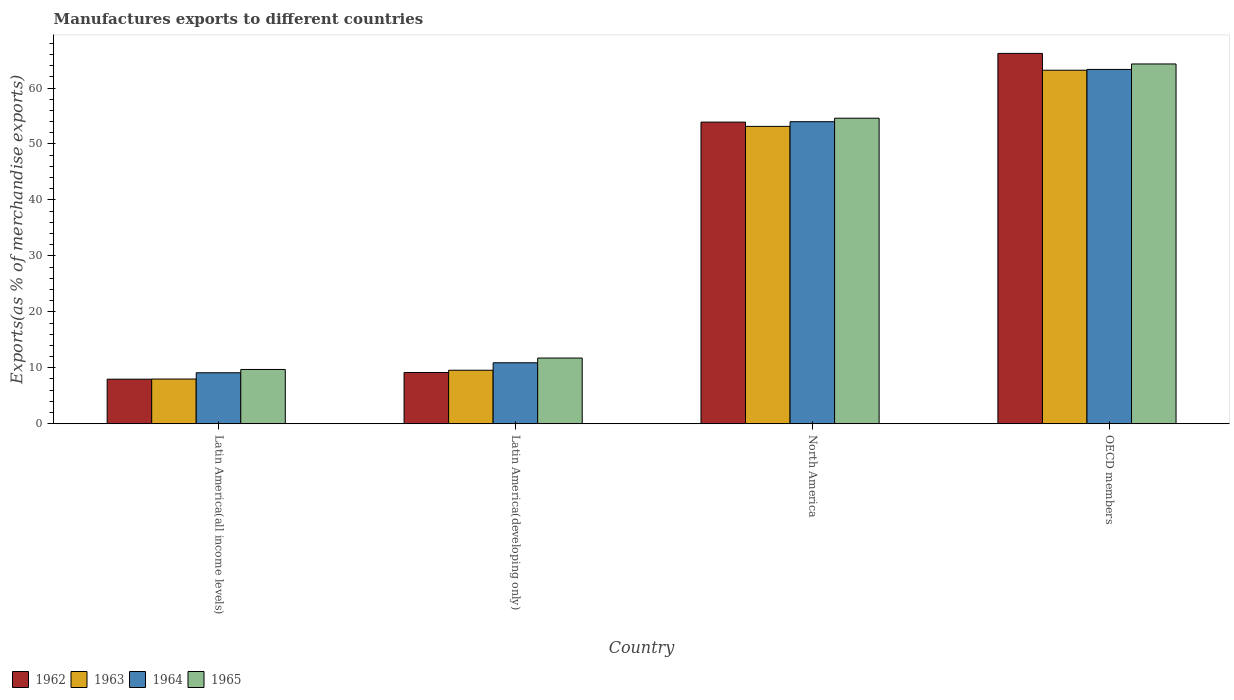How many groups of bars are there?
Your answer should be very brief. 4. Are the number of bars per tick equal to the number of legend labels?
Offer a terse response. Yes. What is the label of the 3rd group of bars from the left?
Give a very brief answer. North America. In how many cases, is the number of bars for a given country not equal to the number of legend labels?
Provide a succinct answer. 0. What is the percentage of exports to different countries in 1962 in OECD members?
Give a very brief answer. 66.19. Across all countries, what is the maximum percentage of exports to different countries in 1965?
Give a very brief answer. 64.3. Across all countries, what is the minimum percentage of exports to different countries in 1964?
Your answer should be very brief. 9.11. In which country was the percentage of exports to different countries in 1963 minimum?
Keep it short and to the point. Latin America(all income levels). What is the total percentage of exports to different countries in 1964 in the graph?
Offer a terse response. 137.31. What is the difference between the percentage of exports to different countries in 1965 in Latin America(all income levels) and that in Latin America(developing only)?
Provide a short and direct response. -2.04. What is the difference between the percentage of exports to different countries in 1963 in Latin America(developing only) and the percentage of exports to different countries in 1964 in North America?
Keep it short and to the point. -44.42. What is the average percentage of exports to different countries in 1962 per country?
Your answer should be very brief. 34.31. What is the difference between the percentage of exports to different countries of/in 1964 and percentage of exports to different countries of/in 1965 in Latin America(developing only)?
Make the answer very short. -0.84. What is the ratio of the percentage of exports to different countries in 1962 in Latin America(all income levels) to that in OECD members?
Provide a short and direct response. 0.12. Is the percentage of exports to different countries in 1965 in Latin America(developing only) less than that in OECD members?
Give a very brief answer. Yes. Is the difference between the percentage of exports to different countries in 1964 in Latin America(developing only) and OECD members greater than the difference between the percentage of exports to different countries in 1965 in Latin America(developing only) and OECD members?
Offer a very short reply. Yes. What is the difference between the highest and the second highest percentage of exports to different countries in 1963?
Ensure brevity in your answer.  -43.59. What is the difference between the highest and the lowest percentage of exports to different countries in 1965?
Your answer should be compact. 54.6. In how many countries, is the percentage of exports to different countries in 1965 greater than the average percentage of exports to different countries in 1965 taken over all countries?
Offer a very short reply. 2. What does the 2nd bar from the right in Latin America(developing only) represents?
Your answer should be very brief. 1964. Is it the case that in every country, the sum of the percentage of exports to different countries in 1965 and percentage of exports to different countries in 1963 is greater than the percentage of exports to different countries in 1964?
Your response must be concise. Yes. How many countries are there in the graph?
Ensure brevity in your answer.  4. Does the graph contain grids?
Ensure brevity in your answer.  No. How many legend labels are there?
Provide a short and direct response. 4. How are the legend labels stacked?
Your response must be concise. Horizontal. What is the title of the graph?
Your answer should be very brief. Manufactures exports to different countries. What is the label or title of the Y-axis?
Make the answer very short. Exports(as % of merchandise exports). What is the Exports(as % of merchandise exports) in 1962 in Latin America(all income levels)?
Provide a succinct answer. 7.96. What is the Exports(as % of merchandise exports) of 1963 in Latin America(all income levels)?
Your answer should be compact. 7.99. What is the Exports(as % of merchandise exports) of 1964 in Latin America(all income levels)?
Keep it short and to the point. 9.11. What is the Exports(as % of merchandise exports) in 1965 in Latin America(all income levels)?
Ensure brevity in your answer.  9.7. What is the Exports(as % of merchandise exports) in 1962 in Latin America(developing only)?
Offer a very short reply. 9.16. What is the Exports(as % of merchandise exports) of 1963 in Latin America(developing only)?
Make the answer very short. 9.56. What is the Exports(as % of merchandise exports) of 1964 in Latin America(developing only)?
Provide a short and direct response. 10.9. What is the Exports(as % of merchandise exports) in 1965 in Latin America(developing only)?
Ensure brevity in your answer.  11.74. What is the Exports(as % of merchandise exports) in 1962 in North America?
Ensure brevity in your answer.  53.91. What is the Exports(as % of merchandise exports) in 1963 in North America?
Give a very brief answer. 53.15. What is the Exports(as % of merchandise exports) of 1964 in North America?
Provide a succinct answer. 53.98. What is the Exports(as % of merchandise exports) of 1965 in North America?
Your response must be concise. 54.61. What is the Exports(as % of merchandise exports) of 1962 in OECD members?
Ensure brevity in your answer.  66.19. What is the Exports(as % of merchandise exports) of 1963 in OECD members?
Provide a short and direct response. 63.18. What is the Exports(as % of merchandise exports) of 1964 in OECD members?
Your answer should be very brief. 63.32. What is the Exports(as % of merchandise exports) of 1965 in OECD members?
Offer a terse response. 64.3. Across all countries, what is the maximum Exports(as % of merchandise exports) of 1962?
Give a very brief answer. 66.19. Across all countries, what is the maximum Exports(as % of merchandise exports) in 1963?
Make the answer very short. 63.18. Across all countries, what is the maximum Exports(as % of merchandise exports) of 1964?
Make the answer very short. 63.32. Across all countries, what is the maximum Exports(as % of merchandise exports) in 1965?
Give a very brief answer. 64.3. Across all countries, what is the minimum Exports(as % of merchandise exports) in 1962?
Provide a succinct answer. 7.96. Across all countries, what is the minimum Exports(as % of merchandise exports) in 1963?
Offer a terse response. 7.99. Across all countries, what is the minimum Exports(as % of merchandise exports) of 1964?
Your response must be concise. 9.11. Across all countries, what is the minimum Exports(as % of merchandise exports) of 1965?
Make the answer very short. 9.7. What is the total Exports(as % of merchandise exports) of 1962 in the graph?
Your answer should be very brief. 137.22. What is the total Exports(as % of merchandise exports) in 1963 in the graph?
Offer a terse response. 133.88. What is the total Exports(as % of merchandise exports) of 1964 in the graph?
Your answer should be very brief. 137.31. What is the total Exports(as % of merchandise exports) of 1965 in the graph?
Ensure brevity in your answer.  140.35. What is the difference between the Exports(as % of merchandise exports) of 1962 in Latin America(all income levels) and that in Latin America(developing only)?
Provide a short and direct response. -1.2. What is the difference between the Exports(as % of merchandise exports) of 1963 in Latin America(all income levels) and that in Latin America(developing only)?
Provide a short and direct response. -1.57. What is the difference between the Exports(as % of merchandise exports) in 1964 in Latin America(all income levels) and that in Latin America(developing only)?
Give a very brief answer. -1.78. What is the difference between the Exports(as % of merchandise exports) in 1965 in Latin America(all income levels) and that in Latin America(developing only)?
Give a very brief answer. -2.04. What is the difference between the Exports(as % of merchandise exports) in 1962 in Latin America(all income levels) and that in North America?
Offer a terse response. -45.94. What is the difference between the Exports(as % of merchandise exports) of 1963 in Latin America(all income levels) and that in North America?
Ensure brevity in your answer.  -45.16. What is the difference between the Exports(as % of merchandise exports) in 1964 in Latin America(all income levels) and that in North America?
Make the answer very short. -44.87. What is the difference between the Exports(as % of merchandise exports) of 1965 in Latin America(all income levels) and that in North America?
Provide a succinct answer. -44.91. What is the difference between the Exports(as % of merchandise exports) of 1962 in Latin America(all income levels) and that in OECD members?
Offer a terse response. -58.23. What is the difference between the Exports(as % of merchandise exports) in 1963 in Latin America(all income levels) and that in OECD members?
Provide a short and direct response. -55.19. What is the difference between the Exports(as % of merchandise exports) in 1964 in Latin America(all income levels) and that in OECD members?
Your answer should be very brief. -54.21. What is the difference between the Exports(as % of merchandise exports) of 1965 in Latin America(all income levels) and that in OECD members?
Ensure brevity in your answer.  -54.6. What is the difference between the Exports(as % of merchandise exports) of 1962 in Latin America(developing only) and that in North America?
Give a very brief answer. -44.75. What is the difference between the Exports(as % of merchandise exports) of 1963 in Latin America(developing only) and that in North America?
Your response must be concise. -43.59. What is the difference between the Exports(as % of merchandise exports) in 1964 in Latin America(developing only) and that in North America?
Offer a very short reply. -43.09. What is the difference between the Exports(as % of merchandise exports) of 1965 in Latin America(developing only) and that in North America?
Provide a short and direct response. -42.87. What is the difference between the Exports(as % of merchandise exports) of 1962 in Latin America(developing only) and that in OECD members?
Provide a short and direct response. -57.03. What is the difference between the Exports(as % of merchandise exports) of 1963 in Latin America(developing only) and that in OECD members?
Keep it short and to the point. -53.62. What is the difference between the Exports(as % of merchandise exports) in 1964 in Latin America(developing only) and that in OECD members?
Provide a short and direct response. -52.43. What is the difference between the Exports(as % of merchandise exports) of 1965 in Latin America(developing only) and that in OECD members?
Provide a short and direct response. -52.56. What is the difference between the Exports(as % of merchandise exports) of 1962 in North America and that in OECD members?
Make the answer very short. -12.28. What is the difference between the Exports(as % of merchandise exports) in 1963 in North America and that in OECD members?
Make the answer very short. -10.03. What is the difference between the Exports(as % of merchandise exports) of 1964 in North America and that in OECD members?
Make the answer very short. -9.34. What is the difference between the Exports(as % of merchandise exports) of 1965 in North America and that in OECD members?
Ensure brevity in your answer.  -9.7. What is the difference between the Exports(as % of merchandise exports) of 1962 in Latin America(all income levels) and the Exports(as % of merchandise exports) of 1963 in Latin America(developing only)?
Offer a very short reply. -1.6. What is the difference between the Exports(as % of merchandise exports) in 1962 in Latin America(all income levels) and the Exports(as % of merchandise exports) in 1964 in Latin America(developing only)?
Your answer should be very brief. -2.93. What is the difference between the Exports(as % of merchandise exports) in 1962 in Latin America(all income levels) and the Exports(as % of merchandise exports) in 1965 in Latin America(developing only)?
Offer a terse response. -3.78. What is the difference between the Exports(as % of merchandise exports) of 1963 in Latin America(all income levels) and the Exports(as % of merchandise exports) of 1964 in Latin America(developing only)?
Your response must be concise. -2.91. What is the difference between the Exports(as % of merchandise exports) of 1963 in Latin America(all income levels) and the Exports(as % of merchandise exports) of 1965 in Latin America(developing only)?
Provide a short and direct response. -3.75. What is the difference between the Exports(as % of merchandise exports) in 1964 in Latin America(all income levels) and the Exports(as % of merchandise exports) in 1965 in Latin America(developing only)?
Keep it short and to the point. -2.63. What is the difference between the Exports(as % of merchandise exports) in 1962 in Latin America(all income levels) and the Exports(as % of merchandise exports) in 1963 in North America?
Offer a very short reply. -45.18. What is the difference between the Exports(as % of merchandise exports) of 1962 in Latin America(all income levels) and the Exports(as % of merchandise exports) of 1964 in North America?
Your response must be concise. -46.02. What is the difference between the Exports(as % of merchandise exports) in 1962 in Latin America(all income levels) and the Exports(as % of merchandise exports) in 1965 in North America?
Ensure brevity in your answer.  -46.64. What is the difference between the Exports(as % of merchandise exports) in 1963 in Latin America(all income levels) and the Exports(as % of merchandise exports) in 1964 in North America?
Give a very brief answer. -45.99. What is the difference between the Exports(as % of merchandise exports) in 1963 in Latin America(all income levels) and the Exports(as % of merchandise exports) in 1965 in North America?
Your response must be concise. -46.62. What is the difference between the Exports(as % of merchandise exports) of 1964 in Latin America(all income levels) and the Exports(as % of merchandise exports) of 1965 in North America?
Offer a terse response. -45.49. What is the difference between the Exports(as % of merchandise exports) of 1962 in Latin America(all income levels) and the Exports(as % of merchandise exports) of 1963 in OECD members?
Your response must be concise. -55.22. What is the difference between the Exports(as % of merchandise exports) in 1962 in Latin America(all income levels) and the Exports(as % of merchandise exports) in 1964 in OECD members?
Your answer should be compact. -55.36. What is the difference between the Exports(as % of merchandise exports) of 1962 in Latin America(all income levels) and the Exports(as % of merchandise exports) of 1965 in OECD members?
Offer a terse response. -56.34. What is the difference between the Exports(as % of merchandise exports) in 1963 in Latin America(all income levels) and the Exports(as % of merchandise exports) in 1964 in OECD members?
Offer a very short reply. -55.34. What is the difference between the Exports(as % of merchandise exports) of 1963 in Latin America(all income levels) and the Exports(as % of merchandise exports) of 1965 in OECD members?
Provide a short and direct response. -56.31. What is the difference between the Exports(as % of merchandise exports) of 1964 in Latin America(all income levels) and the Exports(as % of merchandise exports) of 1965 in OECD members?
Offer a very short reply. -55.19. What is the difference between the Exports(as % of merchandise exports) in 1962 in Latin America(developing only) and the Exports(as % of merchandise exports) in 1963 in North America?
Ensure brevity in your answer.  -43.99. What is the difference between the Exports(as % of merchandise exports) in 1962 in Latin America(developing only) and the Exports(as % of merchandise exports) in 1964 in North America?
Keep it short and to the point. -44.82. What is the difference between the Exports(as % of merchandise exports) in 1962 in Latin America(developing only) and the Exports(as % of merchandise exports) in 1965 in North America?
Make the answer very short. -45.45. What is the difference between the Exports(as % of merchandise exports) in 1963 in Latin America(developing only) and the Exports(as % of merchandise exports) in 1964 in North America?
Keep it short and to the point. -44.42. What is the difference between the Exports(as % of merchandise exports) of 1963 in Latin America(developing only) and the Exports(as % of merchandise exports) of 1965 in North America?
Offer a very short reply. -45.04. What is the difference between the Exports(as % of merchandise exports) of 1964 in Latin America(developing only) and the Exports(as % of merchandise exports) of 1965 in North America?
Ensure brevity in your answer.  -43.71. What is the difference between the Exports(as % of merchandise exports) of 1962 in Latin America(developing only) and the Exports(as % of merchandise exports) of 1963 in OECD members?
Provide a short and direct response. -54.02. What is the difference between the Exports(as % of merchandise exports) of 1962 in Latin America(developing only) and the Exports(as % of merchandise exports) of 1964 in OECD members?
Your response must be concise. -54.16. What is the difference between the Exports(as % of merchandise exports) of 1962 in Latin America(developing only) and the Exports(as % of merchandise exports) of 1965 in OECD members?
Provide a succinct answer. -55.14. What is the difference between the Exports(as % of merchandise exports) of 1963 in Latin America(developing only) and the Exports(as % of merchandise exports) of 1964 in OECD members?
Your response must be concise. -53.76. What is the difference between the Exports(as % of merchandise exports) of 1963 in Latin America(developing only) and the Exports(as % of merchandise exports) of 1965 in OECD members?
Your answer should be compact. -54.74. What is the difference between the Exports(as % of merchandise exports) of 1964 in Latin America(developing only) and the Exports(as % of merchandise exports) of 1965 in OECD members?
Give a very brief answer. -53.41. What is the difference between the Exports(as % of merchandise exports) of 1962 in North America and the Exports(as % of merchandise exports) of 1963 in OECD members?
Your answer should be very brief. -9.27. What is the difference between the Exports(as % of merchandise exports) of 1962 in North America and the Exports(as % of merchandise exports) of 1964 in OECD members?
Provide a succinct answer. -9.42. What is the difference between the Exports(as % of merchandise exports) of 1962 in North America and the Exports(as % of merchandise exports) of 1965 in OECD members?
Your answer should be very brief. -10.4. What is the difference between the Exports(as % of merchandise exports) of 1963 in North America and the Exports(as % of merchandise exports) of 1964 in OECD members?
Your response must be concise. -10.18. What is the difference between the Exports(as % of merchandise exports) of 1963 in North America and the Exports(as % of merchandise exports) of 1965 in OECD members?
Provide a short and direct response. -11.15. What is the difference between the Exports(as % of merchandise exports) in 1964 in North America and the Exports(as % of merchandise exports) in 1965 in OECD members?
Provide a short and direct response. -10.32. What is the average Exports(as % of merchandise exports) of 1962 per country?
Ensure brevity in your answer.  34.31. What is the average Exports(as % of merchandise exports) of 1963 per country?
Your answer should be compact. 33.47. What is the average Exports(as % of merchandise exports) of 1964 per country?
Offer a terse response. 34.33. What is the average Exports(as % of merchandise exports) of 1965 per country?
Offer a terse response. 35.09. What is the difference between the Exports(as % of merchandise exports) in 1962 and Exports(as % of merchandise exports) in 1963 in Latin America(all income levels)?
Give a very brief answer. -0.02. What is the difference between the Exports(as % of merchandise exports) in 1962 and Exports(as % of merchandise exports) in 1964 in Latin America(all income levels)?
Ensure brevity in your answer.  -1.15. What is the difference between the Exports(as % of merchandise exports) in 1962 and Exports(as % of merchandise exports) in 1965 in Latin America(all income levels)?
Keep it short and to the point. -1.74. What is the difference between the Exports(as % of merchandise exports) in 1963 and Exports(as % of merchandise exports) in 1964 in Latin America(all income levels)?
Your answer should be compact. -1.12. What is the difference between the Exports(as % of merchandise exports) of 1963 and Exports(as % of merchandise exports) of 1965 in Latin America(all income levels)?
Your response must be concise. -1.71. What is the difference between the Exports(as % of merchandise exports) in 1964 and Exports(as % of merchandise exports) in 1965 in Latin America(all income levels)?
Offer a very short reply. -0.59. What is the difference between the Exports(as % of merchandise exports) in 1962 and Exports(as % of merchandise exports) in 1963 in Latin America(developing only)?
Give a very brief answer. -0.4. What is the difference between the Exports(as % of merchandise exports) of 1962 and Exports(as % of merchandise exports) of 1964 in Latin America(developing only)?
Your answer should be very brief. -1.74. What is the difference between the Exports(as % of merchandise exports) of 1962 and Exports(as % of merchandise exports) of 1965 in Latin America(developing only)?
Provide a short and direct response. -2.58. What is the difference between the Exports(as % of merchandise exports) of 1963 and Exports(as % of merchandise exports) of 1964 in Latin America(developing only)?
Keep it short and to the point. -1.33. What is the difference between the Exports(as % of merchandise exports) in 1963 and Exports(as % of merchandise exports) in 1965 in Latin America(developing only)?
Offer a very short reply. -2.18. What is the difference between the Exports(as % of merchandise exports) of 1964 and Exports(as % of merchandise exports) of 1965 in Latin America(developing only)?
Keep it short and to the point. -0.84. What is the difference between the Exports(as % of merchandise exports) in 1962 and Exports(as % of merchandise exports) in 1963 in North America?
Ensure brevity in your answer.  0.76. What is the difference between the Exports(as % of merchandise exports) of 1962 and Exports(as % of merchandise exports) of 1964 in North America?
Ensure brevity in your answer.  -0.08. What is the difference between the Exports(as % of merchandise exports) in 1962 and Exports(as % of merchandise exports) in 1965 in North America?
Your response must be concise. -0.7. What is the difference between the Exports(as % of merchandise exports) of 1963 and Exports(as % of merchandise exports) of 1964 in North America?
Provide a succinct answer. -0.84. What is the difference between the Exports(as % of merchandise exports) of 1963 and Exports(as % of merchandise exports) of 1965 in North America?
Your response must be concise. -1.46. What is the difference between the Exports(as % of merchandise exports) in 1964 and Exports(as % of merchandise exports) in 1965 in North America?
Keep it short and to the point. -0.62. What is the difference between the Exports(as % of merchandise exports) of 1962 and Exports(as % of merchandise exports) of 1963 in OECD members?
Offer a terse response. 3.01. What is the difference between the Exports(as % of merchandise exports) of 1962 and Exports(as % of merchandise exports) of 1964 in OECD members?
Keep it short and to the point. 2.87. What is the difference between the Exports(as % of merchandise exports) in 1962 and Exports(as % of merchandise exports) in 1965 in OECD members?
Your answer should be compact. 1.89. What is the difference between the Exports(as % of merchandise exports) of 1963 and Exports(as % of merchandise exports) of 1964 in OECD members?
Your answer should be compact. -0.14. What is the difference between the Exports(as % of merchandise exports) in 1963 and Exports(as % of merchandise exports) in 1965 in OECD members?
Keep it short and to the point. -1.12. What is the difference between the Exports(as % of merchandise exports) of 1964 and Exports(as % of merchandise exports) of 1965 in OECD members?
Give a very brief answer. -0.98. What is the ratio of the Exports(as % of merchandise exports) of 1962 in Latin America(all income levels) to that in Latin America(developing only)?
Offer a terse response. 0.87. What is the ratio of the Exports(as % of merchandise exports) of 1963 in Latin America(all income levels) to that in Latin America(developing only)?
Offer a terse response. 0.84. What is the ratio of the Exports(as % of merchandise exports) in 1964 in Latin America(all income levels) to that in Latin America(developing only)?
Provide a short and direct response. 0.84. What is the ratio of the Exports(as % of merchandise exports) in 1965 in Latin America(all income levels) to that in Latin America(developing only)?
Offer a terse response. 0.83. What is the ratio of the Exports(as % of merchandise exports) of 1962 in Latin America(all income levels) to that in North America?
Offer a very short reply. 0.15. What is the ratio of the Exports(as % of merchandise exports) of 1963 in Latin America(all income levels) to that in North America?
Your answer should be very brief. 0.15. What is the ratio of the Exports(as % of merchandise exports) in 1964 in Latin America(all income levels) to that in North America?
Ensure brevity in your answer.  0.17. What is the ratio of the Exports(as % of merchandise exports) in 1965 in Latin America(all income levels) to that in North America?
Your answer should be very brief. 0.18. What is the ratio of the Exports(as % of merchandise exports) in 1962 in Latin America(all income levels) to that in OECD members?
Your response must be concise. 0.12. What is the ratio of the Exports(as % of merchandise exports) in 1963 in Latin America(all income levels) to that in OECD members?
Provide a short and direct response. 0.13. What is the ratio of the Exports(as % of merchandise exports) of 1964 in Latin America(all income levels) to that in OECD members?
Provide a succinct answer. 0.14. What is the ratio of the Exports(as % of merchandise exports) in 1965 in Latin America(all income levels) to that in OECD members?
Provide a succinct answer. 0.15. What is the ratio of the Exports(as % of merchandise exports) in 1962 in Latin America(developing only) to that in North America?
Your answer should be very brief. 0.17. What is the ratio of the Exports(as % of merchandise exports) in 1963 in Latin America(developing only) to that in North America?
Your answer should be compact. 0.18. What is the ratio of the Exports(as % of merchandise exports) in 1964 in Latin America(developing only) to that in North America?
Make the answer very short. 0.2. What is the ratio of the Exports(as % of merchandise exports) of 1965 in Latin America(developing only) to that in North America?
Offer a very short reply. 0.21. What is the ratio of the Exports(as % of merchandise exports) in 1962 in Latin America(developing only) to that in OECD members?
Offer a terse response. 0.14. What is the ratio of the Exports(as % of merchandise exports) in 1963 in Latin America(developing only) to that in OECD members?
Your answer should be very brief. 0.15. What is the ratio of the Exports(as % of merchandise exports) in 1964 in Latin America(developing only) to that in OECD members?
Ensure brevity in your answer.  0.17. What is the ratio of the Exports(as % of merchandise exports) of 1965 in Latin America(developing only) to that in OECD members?
Offer a very short reply. 0.18. What is the ratio of the Exports(as % of merchandise exports) in 1962 in North America to that in OECD members?
Provide a succinct answer. 0.81. What is the ratio of the Exports(as % of merchandise exports) of 1963 in North America to that in OECD members?
Provide a short and direct response. 0.84. What is the ratio of the Exports(as % of merchandise exports) in 1964 in North America to that in OECD members?
Give a very brief answer. 0.85. What is the ratio of the Exports(as % of merchandise exports) of 1965 in North America to that in OECD members?
Keep it short and to the point. 0.85. What is the difference between the highest and the second highest Exports(as % of merchandise exports) in 1962?
Ensure brevity in your answer.  12.28. What is the difference between the highest and the second highest Exports(as % of merchandise exports) of 1963?
Ensure brevity in your answer.  10.03. What is the difference between the highest and the second highest Exports(as % of merchandise exports) of 1964?
Keep it short and to the point. 9.34. What is the difference between the highest and the second highest Exports(as % of merchandise exports) in 1965?
Your response must be concise. 9.7. What is the difference between the highest and the lowest Exports(as % of merchandise exports) of 1962?
Your response must be concise. 58.23. What is the difference between the highest and the lowest Exports(as % of merchandise exports) of 1963?
Your response must be concise. 55.19. What is the difference between the highest and the lowest Exports(as % of merchandise exports) in 1964?
Your answer should be very brief. 54.21. What is the difference between the highest and the lowest Exports(as % of merchandise exports) in 1965?
Your response must be concise. 54.6. 